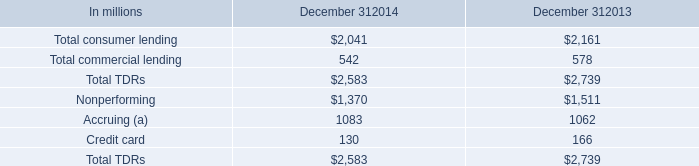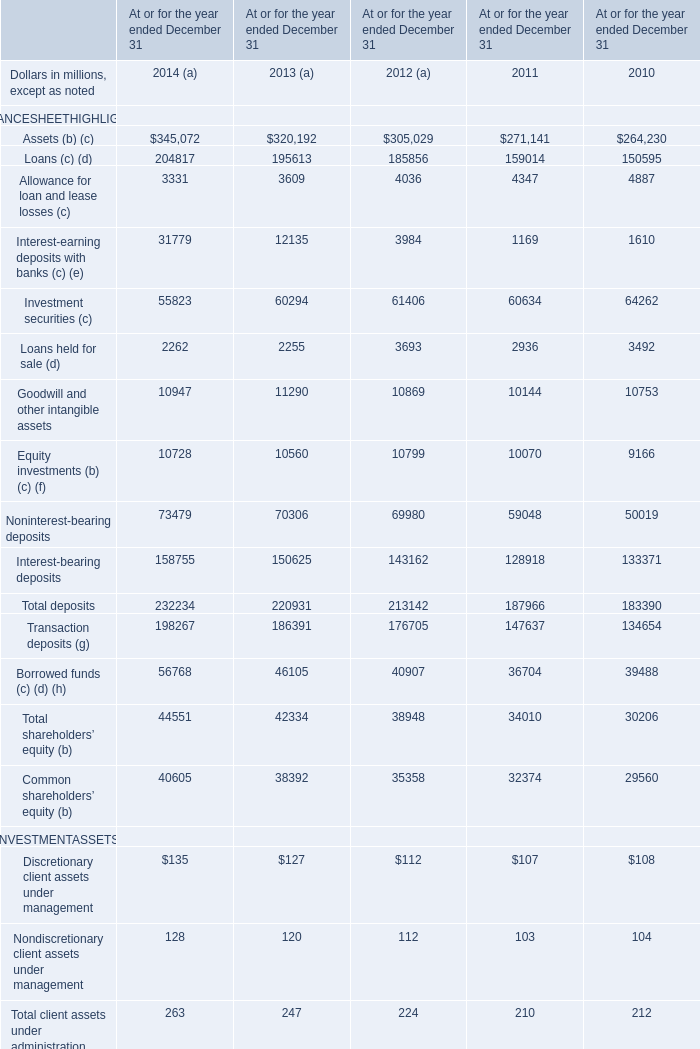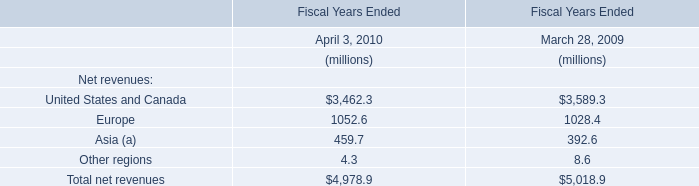In which year the sum of Assets (b) (c) has the highest value? 
Answer: 2014. 